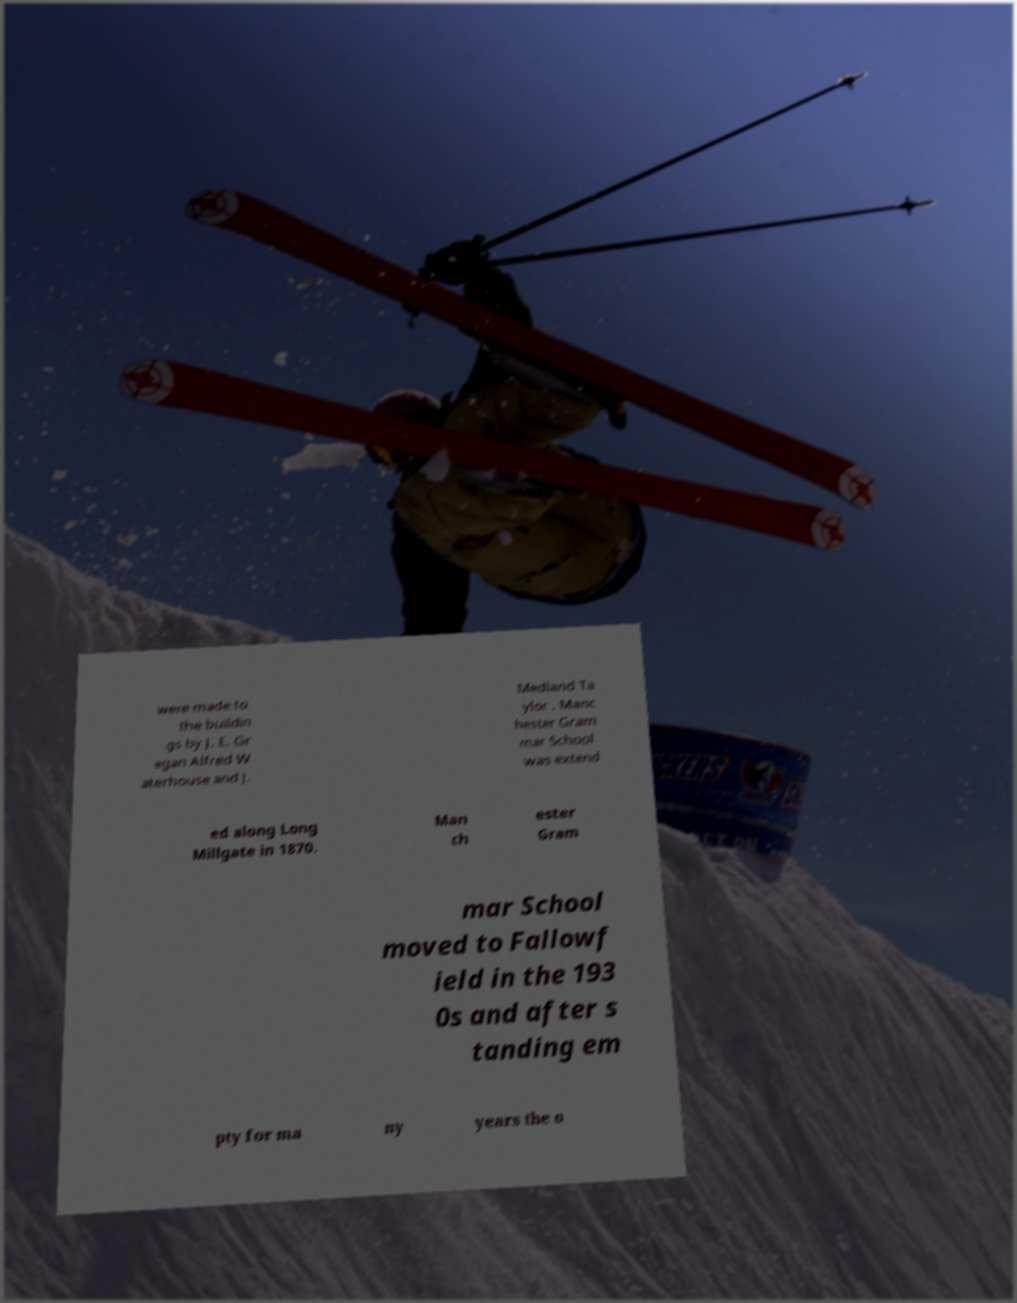There's text embedded in this image that I need extracted. Can you transcribe it verbatim? were made to the buildin gs by J. E. Gr egan Alfred W aterhouse and J. Medland Ta ylor . Manc hester Gram mar School was extend ed along Long Millgate in 1870. Man ch ester Gram mar School moved to Fallowf ield in the 193 0s and after s tanding em pty for ma ny years the o 